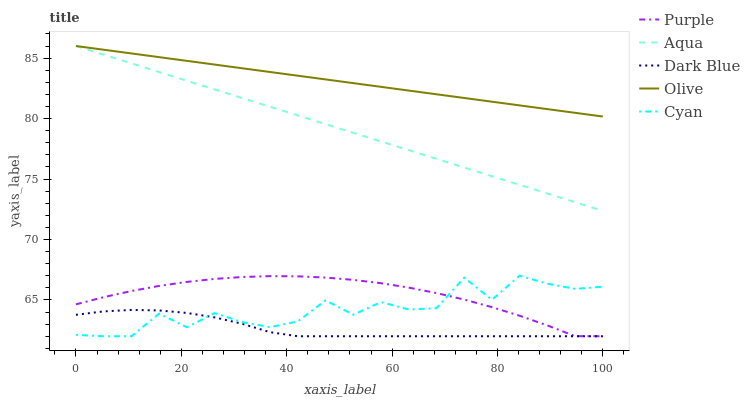Does Dark Blue have the minimum area under the curve?
Answer yes or no. Yes. Does Olive have the maximum area under the curve?
Answer yes or no. Yes. Does Cyan have the minimum area under the curve?
Answer yes or no. No. Does Cyan have the maximum area under the curve?
Answer yes or no. No. Is Aqua the smoothest?
Answer yes or no. Yes. Is Cyan the roughest?
Answer yes or no. Yes. Is Dark Blue the smoothest?
Answer yes or no. No. Is Dark Blue the roughest?
Answer yes or no. No. Does Purple have the lowest value?
Answer yes or no. Yes. Does Aqua have the lowest value?
Answer yes or no. No. Does Olive have the highest value?
Answer yes or no. Yes. Does Cyan have the highest value?
Answer yes or no. No. Is Dark Blue less than Aqua?
Answer yes or no. Yes. Is Olive greater than Dark Blue?
Answer yes or no. Yes. Does Cyan intersect Dark Blue?
Answer yes or no. Yes. Is Cyan less than Dark Blue?
Answer yes or no. No. Is Cyan greater than Dark Blue?
Answer yes or no. No. Does Dark Blue intersect Aqua?
Answer yes or no. No. 